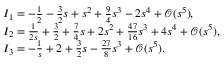<formula> <loc_0><loc_0><loc_500><loc_500>\begin{array} { r l } & { I _ { 1 } = - \frac { 1 } { 2 } - \frac { 3 } { 2 } s + s ^ { 2 } + \frac { 9 } { 4 } s ^ { 3 } - 2 s ^ { 4 } + \mathcal { O } ( s ^ { 5 } ) , } \\ & { I _ { 2 } = \frac { 1 } { 2 s } + \frac { 3 } { 2 } + \frac { 7 } { 4 } s + 2 s ^ { 2 } + \frac { 4 7 } { 1 6 } s ^ { 3 } + 4 s ^ { 4 } + \mathcal { O } ( s ^ { 5 } ) , } \\ & { I _ { 3 } = - \frac { 1 } { s } + 2 + \frac { 3 } { 2 } s - \frac { 2 7 } { 8 } s ^ { 3 } + \mathcal { O } ( s ^ { 5 } ) . } \end{array}</formula> 